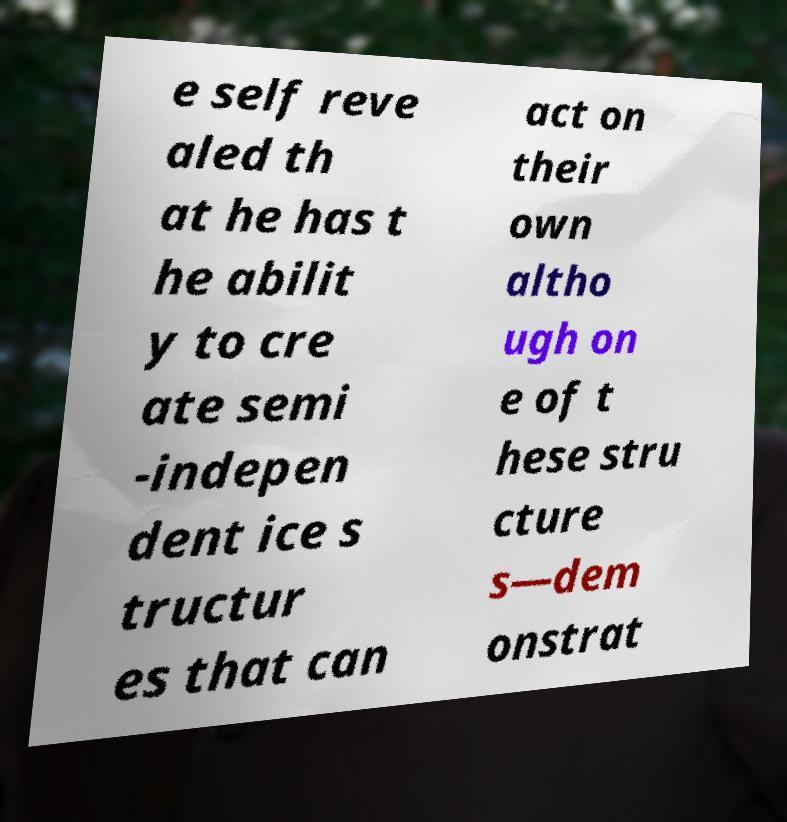Please identify and transcribe the text found in this image. e self reve aled th at he has t he abilit y to cre ate semi -indepen dent ice s tructur es that can act on their own altho ugh on e of t hese stru cture s—dem onstrat 